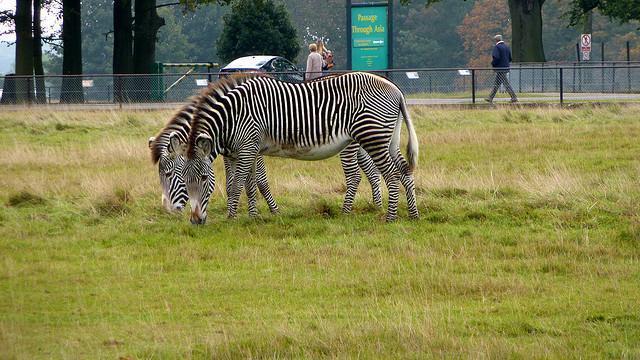How many zebras are visible?
Give a very brief answer. 2. 